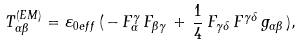Convert formula to latex. <formula><loc_0><loc_0><loc_500><loc_500>T ^ { ( E M ) } _ { \alpha \beta } = { \varepsilon } _ { 0 e f f } \, ( \, - \, F ^ { \gamma } _ { \alpha } \, F _ { \beta \gamma } \, + \, \frac { 1 } { 4 } \, F _ { \gamma \delta } \, F ^ { \gamma \delta } \, g _ { \alpha \beta } \, ) ,</formula> 